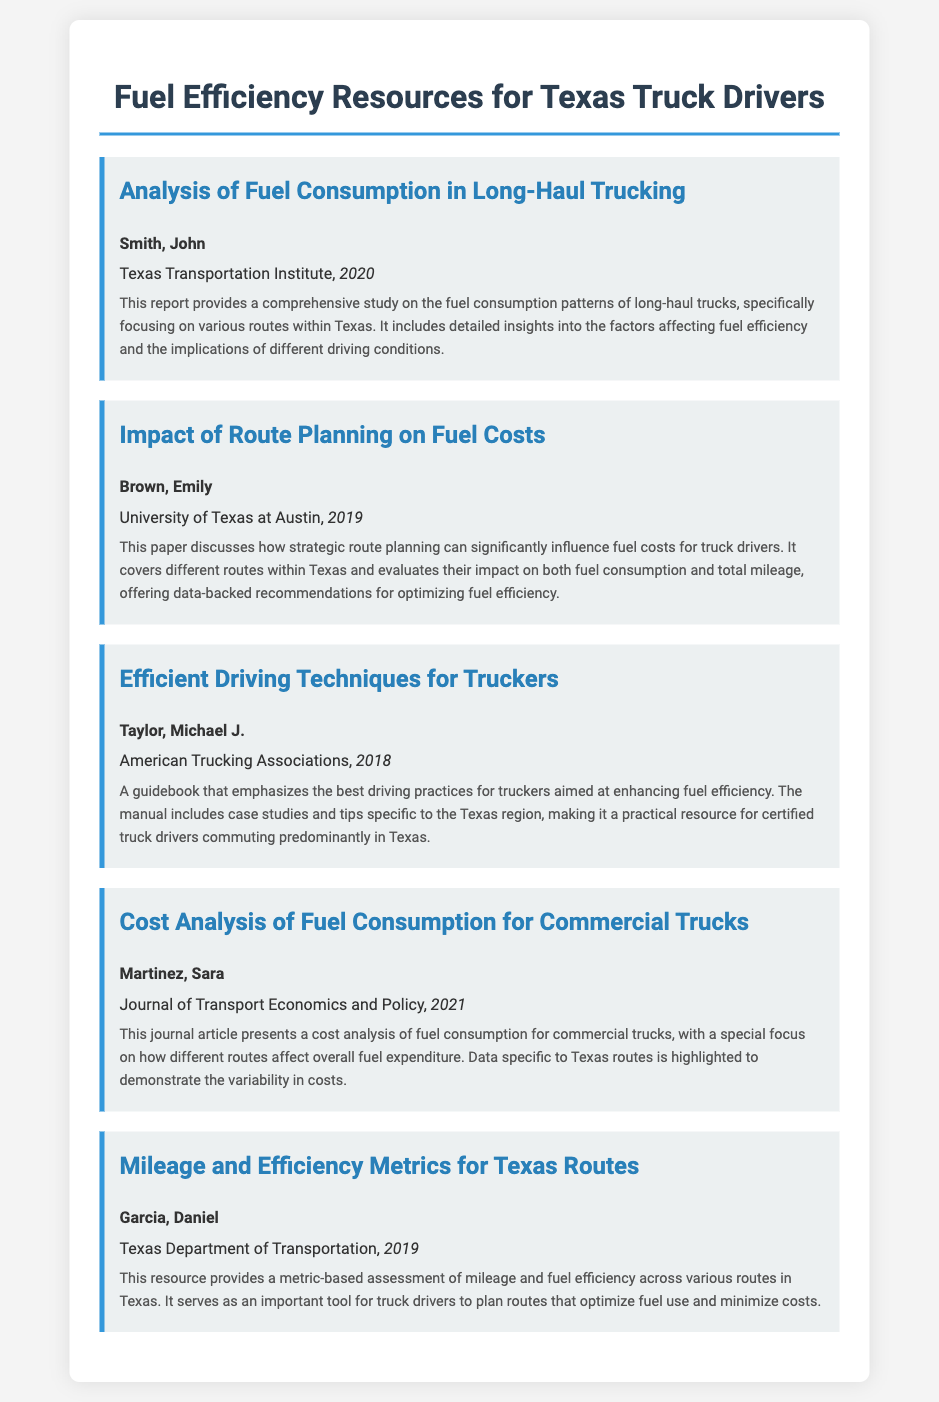what is the title of the first item? The title of the first item is stated in the document under the heading for the bibliography entry.
Answer: Analysis of Fuel Consumption in Long-Haul Trucking who authored the second bibliography item? The author of the second bibliography item is listed right after the title.
Answer: Brown, Emily which year was the guidebook "Efficient Driving Techniques for Truckers" published? The year of publication for the guidebook is mentioned next to the author's name.
Answer: 2018 how many entries are listed in the bibliography? The total entries can be counted based on the number of bibliography-item divs present in the document.
Answer: 5 what organization is associated with the article on cost analysis? The organization is identified in the details of the bibliography item for the cost analysis article.
Answer: Journal of Transport Economics and Policy which author focuses on mileage and efficiency metrics? This information is found in the author section of the last bibliography item.
Answer: Garcia, Daniel what is the main topic of the paper by Brown, Emily? The main topic is specified in the description of the bibliography entry, indicating its focus area.
Answer: Route planning and fuel costs what is the publication year of the last item? The publication year is noted just like other bibliography entries.
Answer: 2019 